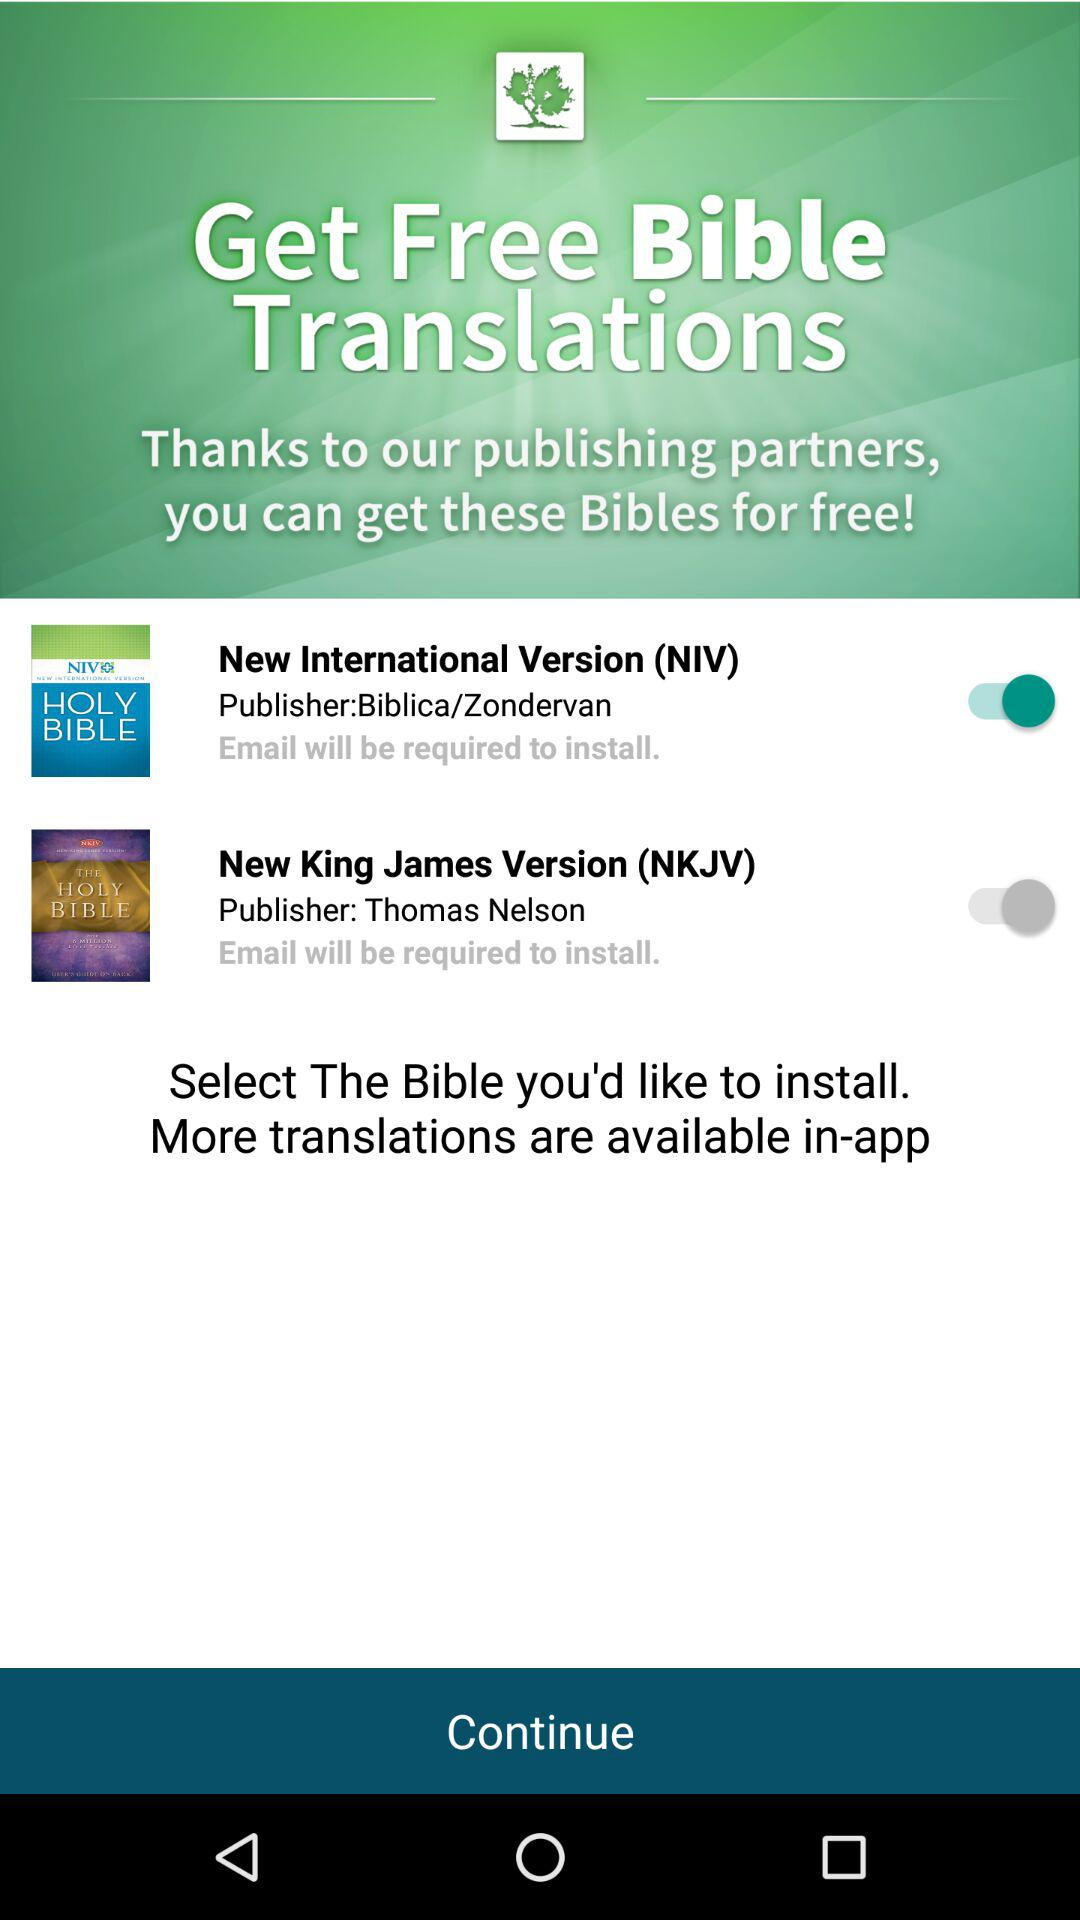What's the status of "New King James Version (NKJV)"? The status of "New King James Version (NKJV)" is "off". 